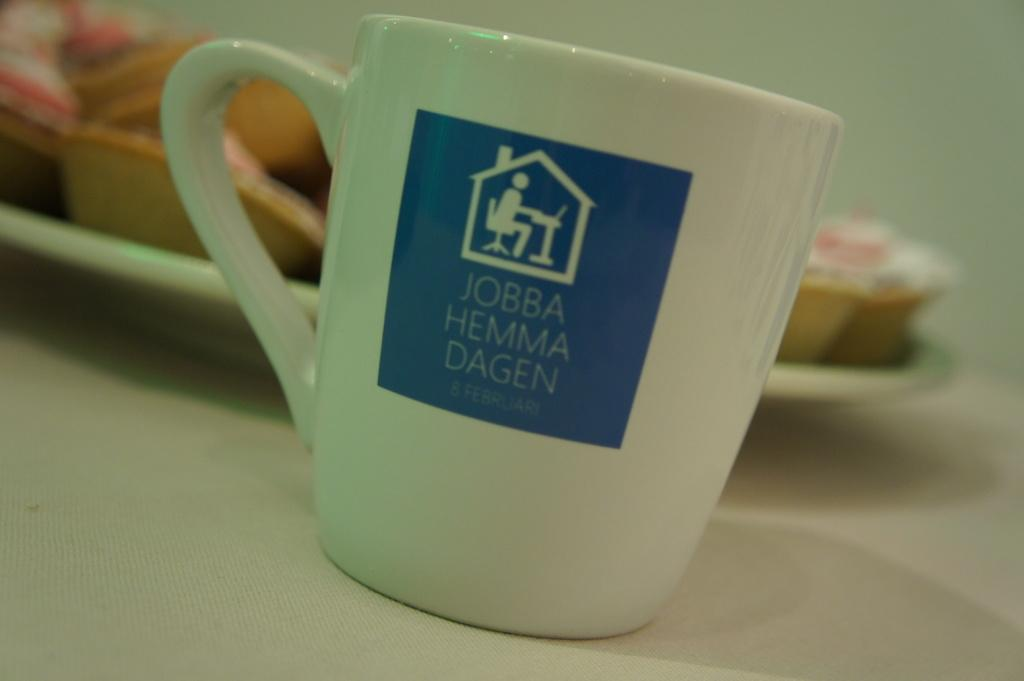Provide a one-sentence caption for the provided image. A white coffee mug that says Jobba Hemma Dagen on the side. 